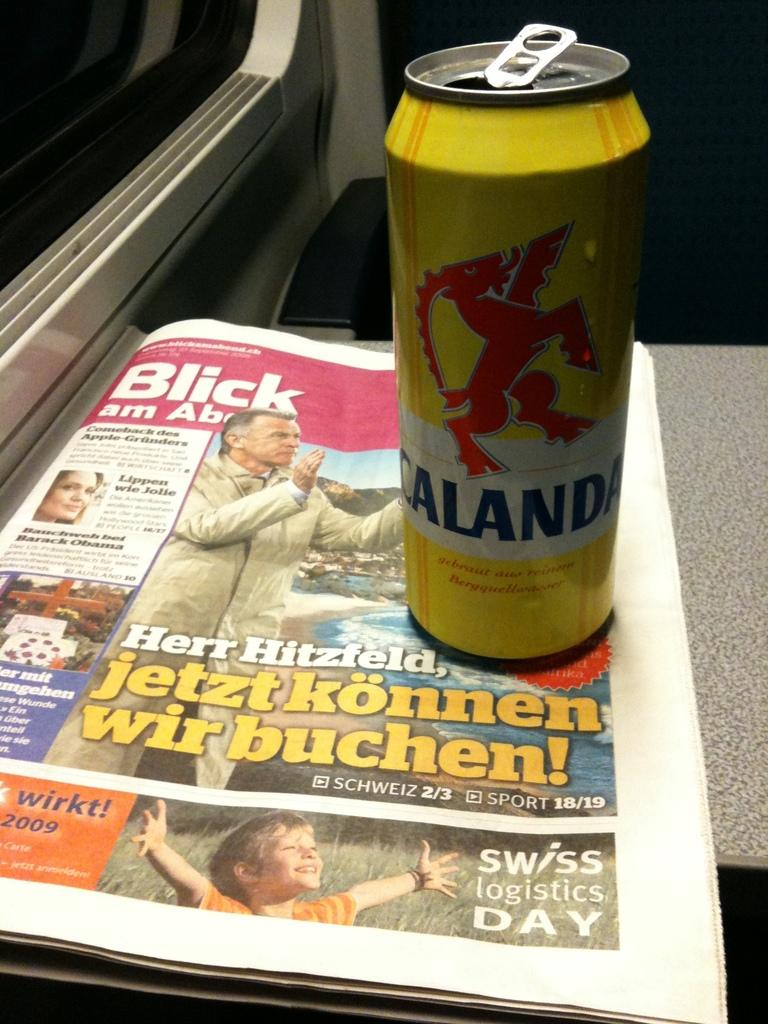<image>
Give a short and clear explanation of the subsequent image. A drink can sits on top of a newspaper that says Herr Hitzfeld. 